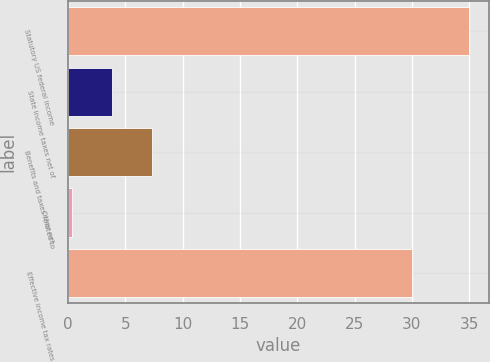Convert chart to OTSL. <chart><loc_0><loc_0><loc_500><loc_500><bar_chart><fcel>Statutory US federal income<fcel>State income taxes net of<fcel>Benefits and taxes related to<fcel>Other net<fcel>Effective income tax rates<nl><fcel>35<fcel>3.86<fcel>7.32<fcel>0.4<fcel>30<nl></chart> 